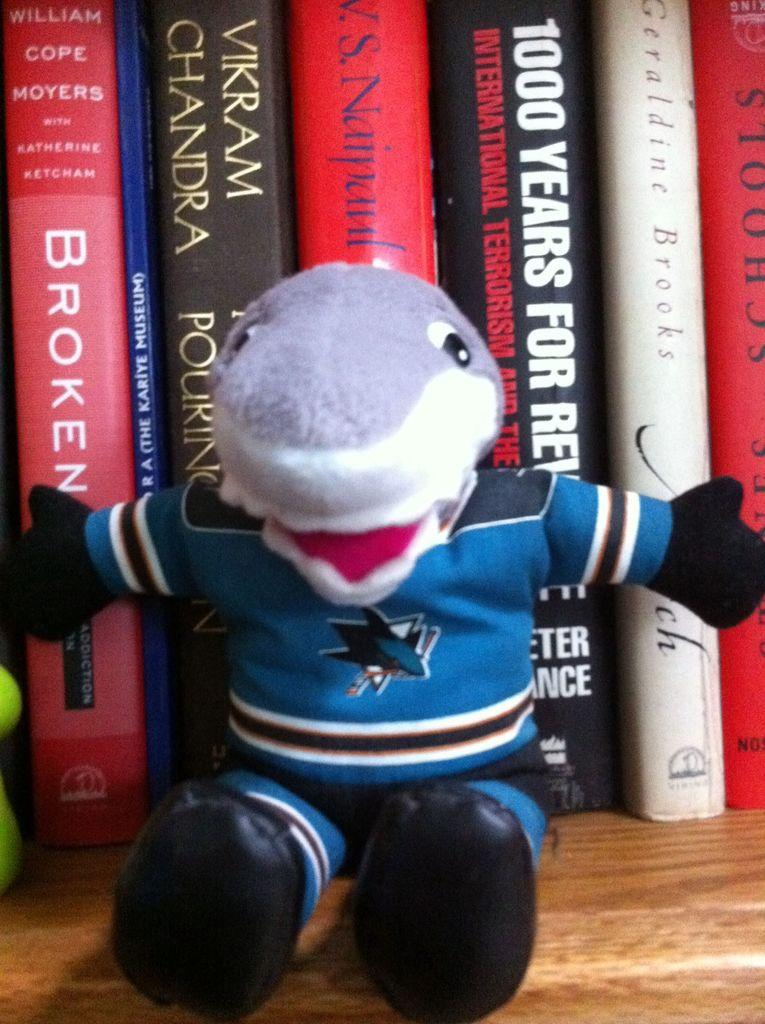<image>
Render a clear and concise summary of the photo. The red book on the left is written by William Cope Moyers 